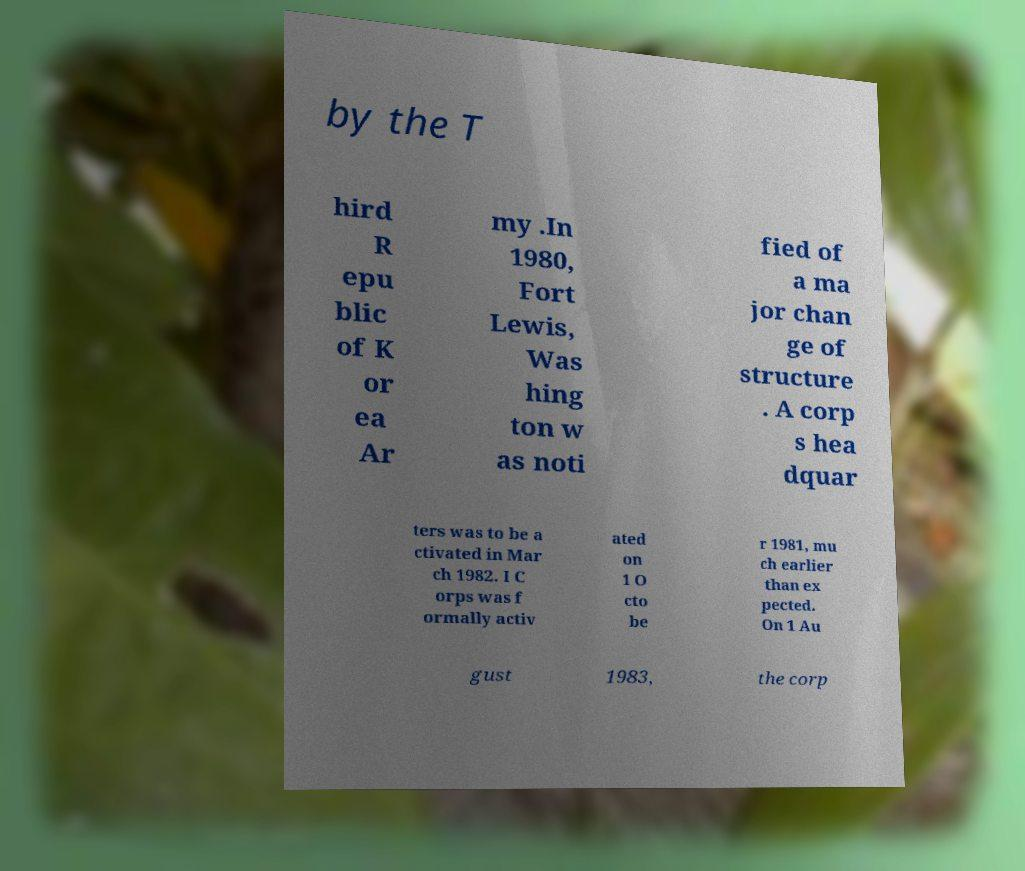Please identify and transcribe the text found in this image. by the T hird R epu blic of K or ea Ar my .In 1980, Fort Lewis, Was hing ton w as noti fied of a ma jor chan ge of structure . A corp s hea dquar ters was to be a ctivated in Mar ch 1982. I C orps was f ormally activ ated on 1 O cto be r 1981, mu ch earlier than ex pected. On 1 Au gust 1983, the corp 